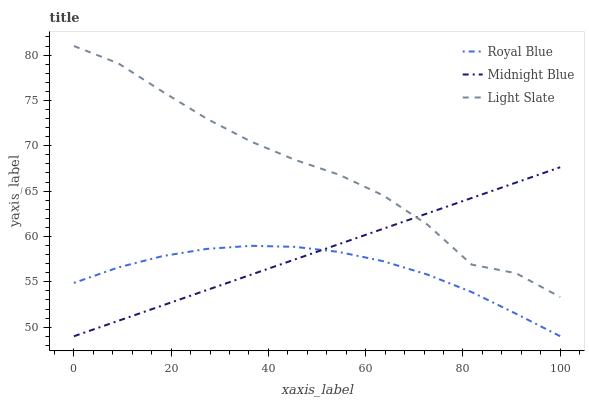Does Royal Blue have the minimum area under the curve?
Answer yes or no. Yes. Does Light Slate have the maximum area under the curve?
Answer yes or no. Yes. Does Midnight Blue have the minimum area under the curve?
Answer yes or no. No. Does Midnight Blue have the maximum area under the curve?
Answer yes or no. No. Is Midnight Blue the smoothest?
Answer yes or no. Yes. Is Light Slate the roughest?
Answer yes or no. Yes. Is Royal Blue the smoothest?
Answer yes or no. No. Is Royal Blue the roughest?
Answer yes or no. No. Does Royal Blue have the lowest value?
Answer yes or no. Yes. Does Light Slate have the highest value?
Answer yes or no. Yes. Does Midnight Blue have the highest value?
Answer yes or no. No. Is Royal Blue less than Light Slate?
Answer yes or no. Yes. Is Light Slate greater than Royal Blue?
Answer yes or no. Yes. Does Royal Blue intersect Midnight Blue?
Answer yes or no. Yes. Is Royal Blue less than Midnight Blue?
Answer yes or no. No. Is Royal Blue greater than Midnight Blue?
Answer yes or no. No. Does Royal Blue intersect Light Slate?
Answer yes or no. No. 